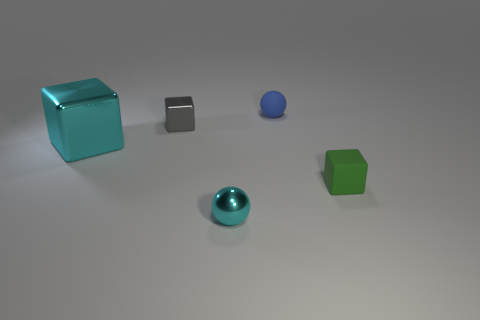There is a small green object that is the same material as the small blue ball; what is its shape?
Ensure brevity in your answer.  Cube. How many blue objects are the same size as the green rubber cube?
Offer a very short reply. 1. There is a gray metallic cube; is it the same size as the thing that is to the right of the small blue matte ball?
Give a very brief answer. Yes. What number of objects are tiny purple things or tiny things?
Ensure brevity in your answer.  4. How many big metal blocks are the same color as the shiny ball?
Keep it short and to the point. 1. What shape is the cyan metal thing that is the same size as the rubber ball?
Ensure brevity in your answer.  Sphere. Is there another thing of the same shape as the tiny green matte thing?
Your response must be concise. Yes. How many small blue objects have the same material as the tiny cyan ball?
Provide a short and direct response. 0. Do the blue thing that is right of the tiny gray metallic cube and the small green object have the same material?
Give a very brief answer. Yes. Are there more tiny green things that are behind the blue ball than blue balls that are in front of the tiny green thing?
Ensure brevity in your answer.  No. 